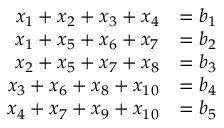<formula> <loc_0><loc_0><loc_500><loc_500>\begin{array} { r l } { x _ { 1 } + x _ { 2 } + x _ { 3 } + x _ { 4 } } & { = b _ { 1 } } \\ { x _ { 1 } + x _ { 5 } + x _ { 6 } + x _ { 7 } } & { = b _ { 2 } } \\ { x _ { 2 } + x _ { 5 } + x _ { 7 } + x _ { 8 } } & { = b _ { 3 } } \\ { x _ { 3 } + x _ { 6 } + x _ { 8 } + x _ { 1 0 } } & { = b _ { 4 } } \\ { x _ { 4 } + x _ { 7 } + x _ { 9 } + x _ { 1 0 } } & { = b _ { 5 } } \end{array}</formula> 